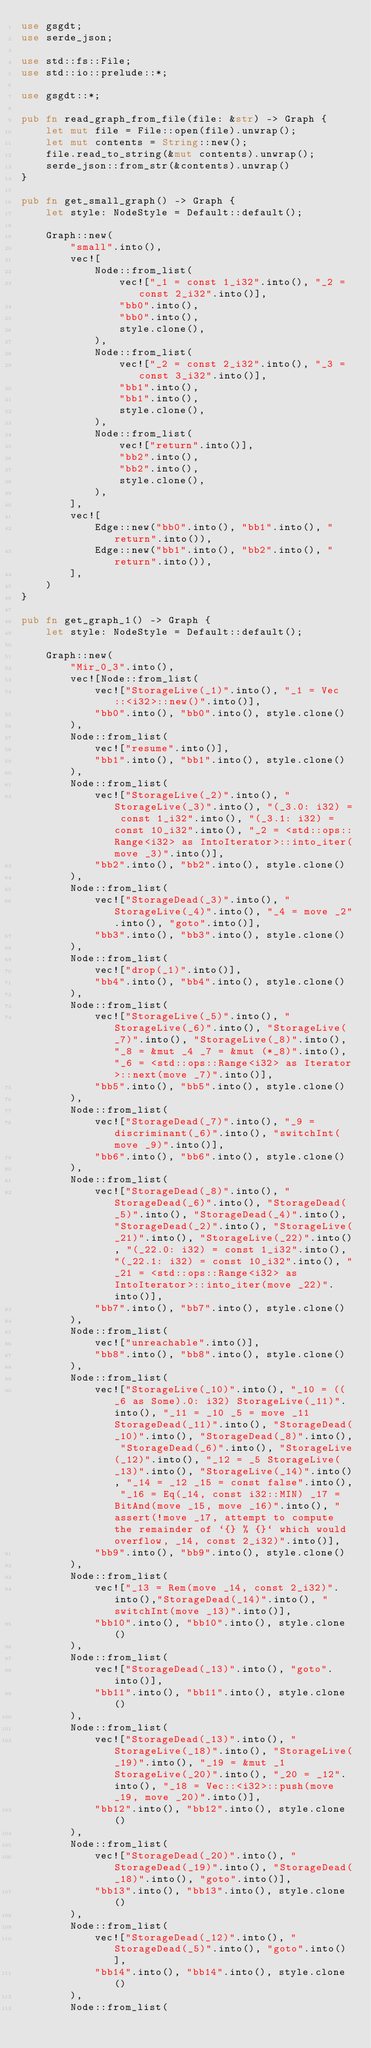<code> <loc_0><loc_0><loc_500><loc_500><_Rust_>use gsgdt;
use serde_json;

use std::fs::File;
use std::io::prelude::*;

use gsgdt::*;

pub fn read_graph_from_file(file: &str) -> Graph {
    let mut file = File::open(file).unwrap();
    let mut contents = String::new();
    file.read_to_string(&mut contents).unwrap();
    serde_json::from_str(&contents).unwrap()
}

pub fn get_small_graph() -> Graph {
    let style: NodeStyle = Default::default();

    Graph::new(
        "small".into(),
        vec![
            Node::from_list(
                vec!["_1 = const 1_i32".into(), "_2 = const 2_i32".into()],
                "bb0".into(),
                "bb0".into(),
                style.clone(),
            ),
            Node::from_list(
                vec!["_2 = const 2_i32".into(), "_3 = const 3_i32".into()],
                "bb1".into(),
                "bb1".into(),
                style.clone(),
            ),
            Node::from_list(
                vec!["return".into()],
                "bb2".into(),
                "bb2".into(),
                style.clone(),
            ),
        ],
        vec![
            Edge::new("bb0".into(), "bb1".into(), "return".into()),
            Edge::new("bb1".into(), "bb2".into(), "return".into()),
        ],
    )
}

pub fn get_graph_1() -> Graph {
    let style: NodeStyle = Default::default();

    Graph::new(
        "Mir_0_3".into(),
        vec![Node::from_list(
            vec!["StorageLive(_1)".into(), "_1 = Vec::<i32>::new()".into()],
            "bb0".into(), "bb0".into(), style.clone()
        ),
        Node::from_list(
            vec!["resume".into()],
            "bb1".into(), "bb1".into(), style.clone()
        ),
        Node::from_list(
            vec!["StorageLive(_2)".into(), "StorageLive(_3)".into(), "(_3.0: i32) = const 1_i32".into(), "(_3.1: i32) = const 10_i32".into(), "_2 = <std::ops::Range<i32> as IntoIterator>::into_iter(move _3)".into()],
            "bb2".into(), "bb2".into(), style.clone()
        ),
        Node::from_list(
            vec!["StorageDead(_3)".into(), "StorageLive(_4)".into(), "_4 = move _2".into(), "goto".into()],
            "bb3".into(), "bb3".into(), style.clone()
        ),
        Node::from_list(
            vec!["drop(_1)".into()],
            "bb4".into(), "bb4".into(), style.clone()
        ),
        Node::from_list(
            vec!["StorageLive(_5)".into(), "StorageLive(_6)".into(), "StorageLive(_7)".into(), "StorageLive(_8)".into(), "_8 = &mut _4 _7 = &mut (*_8)".into(), "_6 = <std::ops::Range<i32> as Iterator>::next(move _7)".into()],
            "bb5".into(), "bb5".into(), style.clone()
        ),
        Node::from_list(
            vec!["StorageDead(_7)".into(), "_9 = discriminant(_6)".into(), "switchInt(move _9)".into()],
            "bb6".into(), "bb6".into(), style.clone()
        ),
        Node::from_list(
            vec!["StorageDead(_8)".into(), "StorageDead(_6)".into(), "StorageDead(_5)".into(), "StorageDead(_4)".into(), "StorageDead(_2)".into(), "StorageLive(_21)".into(), "StorageLive(_22)".into(), "(_22.0: i32) = const 1_i32".into(), "(_22.1: i32) = const 10_i32".into(), "_21 = <std::ops::Range<i32> as IntoIterator>::into_iter(move _22)".into()],
            "bb7".into(), "bb7".into(), style.clone()
        ),
        Node::from_list(
            vec!["unreachable".into()],
            "bb8".into(), "bb8".into(), style.clone()
        ),
        Node::from_list(
            vec!["StorageLive(_10)".into(), "_10 = ((_6 as Some).0: i32) StorageLive(_11)".into(), "_11 = _10 _5 = move _11 StorageDead(_11)".into(), "StorageDead(_10)".into(), "StorageDead(_8)".into(), "StorageDead(_6)".into(), "StorageLive(_12)".into(), "_12 = _5 StorageLive(_13)".into(), "StorageLive(_14)".into(), "_14 = _12 _15 = const false".into(), "_16 = Eq(_14, const i32::MIN) _17 = BitAnd(move _15, move _16)".into(), "assert(!move _17, attempt to compute the remainder of `{} % {}` which would overflow, _14, const 2_i32)".into()],
            "bb9".into(), "bb9".into(), style.clone()
        ),
        Node::from_list(
            vec!["_13 = Rem(move _14, const 2_i32)".into(),"StorageDead(_14)".into(), "switchInt(move _13)".into()],
            "bb10".into(), "bb10".into(), style.clone()
        ),
        Node::from_list(
            vec!["StorageDead(_13)".into(), "goto".into()],
            "bb11".into(), "bb11".into(), style.clone()
        ),
        Node::from_list(
            vec!["StorageDead(_13)".into(), "StorageLive(_18)".into(), "StorageLive(_19)".into(), "_19 = &mut _1 StorageLive(_20)".into(), "_20 = _12".into(), "_18 = Vec::<i32>::push(move _19, move _20)".into()],
            "bb12".into(), "bb12".into(), style.clone()
        ),
        Node::from_list(
            vec!["StorageDead(_20)".into(), "StorageDead(_19)".into(), "StorageDead(_18)".into(), "goto".into()],
            "bb13".into(), "bb13".into(), style.clone()
        ),
        Node::from_list(
            vec!["StorageDead(_12)".into(), "StorageDead(_5)".into(), "goto".into()],
            "bb14".into(), "bb14".into(), style.clone()
        ),
        Node::from_list(</code> 